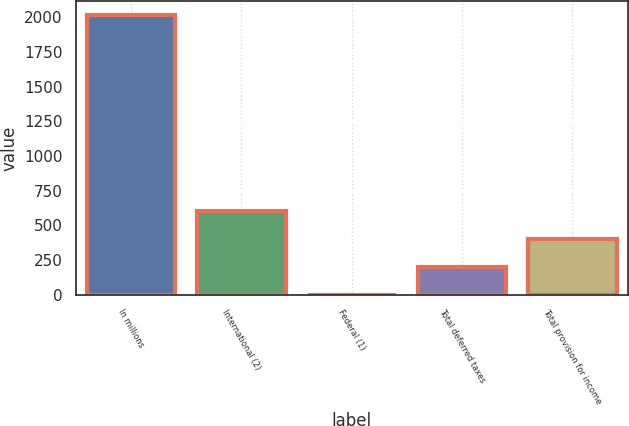<chart> <loc_0><loc_0><loc_500><loc_500><bar_chart><fcel>In millions<fcel>International (2)<fcel>Federal (1)<fcel>Total deferred taxes<fcel>Total provision for income<nl><fcel>2014<fcel>604.69<fcel>0.7<fcel>202.03<fcel>403.36<nl></chart> 